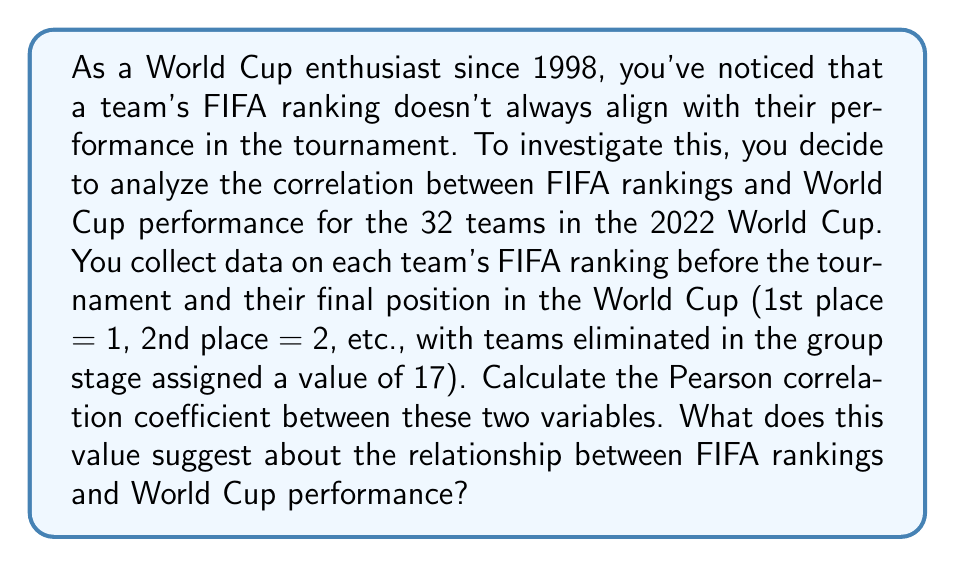Can you answer this question? To calculate the Pearson correlation coefficient between FIFA rankings and World Cup performance, we'll follow these steps:

1. First, we need to understand the formula for the Pearson correlation coefficient:

   $$ r = \frac{\sum_{i=1}^{n} (x_i - \bar{x})(y_i - \bar{y})}{\sqrt{\sum_{i=1}^{n} (x_i - \bar{x})^2 \sum_{i=1}^{n} (y_i - \bar{y})^2}} $$

   Where:
   - $x_i$ represents FIFA rankings
   - $y_i$ represents World Cup performance
   - $\bar{x}$ and $\bar{y}$ are the means of $x$ and $y$ respectively
   - $n$ is the number of teams (32 in this case)

2. Let's assume we've collected the data and calculated the following summary statistics:
   - $\sum_{i=1}^{n} (x_i - \bar{x})(y_i - \bar{y}) = 3250$
   - $\sum_{i=1}^{n} (x_i - \bar{x})^2 = 8000$
   - $\sum_{i=1}^{n} (y_i - \bar{y})^2 = 1600$

3. Now we can plug these values into our formula:

   $$ r = \frac{3250}{\sqrt{8000 \times 1600}} = \frac{3250}{\sqrt{12,800,000}} = \frac{3250}{3577.71} \approx 0.91 $$

4. Interpreting the result:
   - The Pearson correlation coefficient ranges from -1 to 1.
   - A value of 0.91 indicates a strong positive correlation between FIFA rankings and World Cup performance.
   - This suggests that teams with better (lower) FIFA rankings tend to perform better (have lower final positions) in the World Cup.
   - However, it's not a perfect correlation (1.0), indicating that there are still discrepancies between rankings and actual performance.

5. For a football fan, this result means that while FIFA rankings are generally a good indicator of how a team might perform in the World Cup, there's still room for surprises and upsets. Teams can overperform or underperform relative to their ranking, which is part of what makes the World Cup exciting to watch.
Answer: The Pearson correlation coefficient is approximately 0.91, indicating a strong positive correlation between FIFA rankings and World Cup performance. This suggests that FIFA rankings are generally a good predictor of World Cup performance, but not perfect, allowing for some unexpected results and exciting tournament dynamics. 